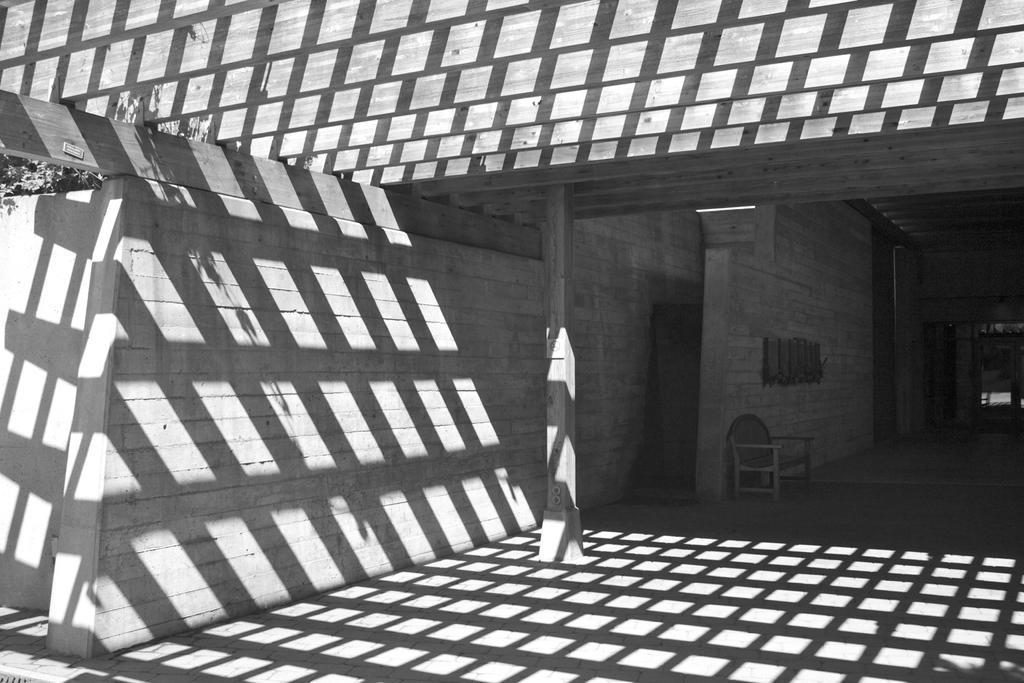Could you give a brief overview of what you see in this image? This is a black and white image, in this image there is an entrance to a house in that there is a chair. 